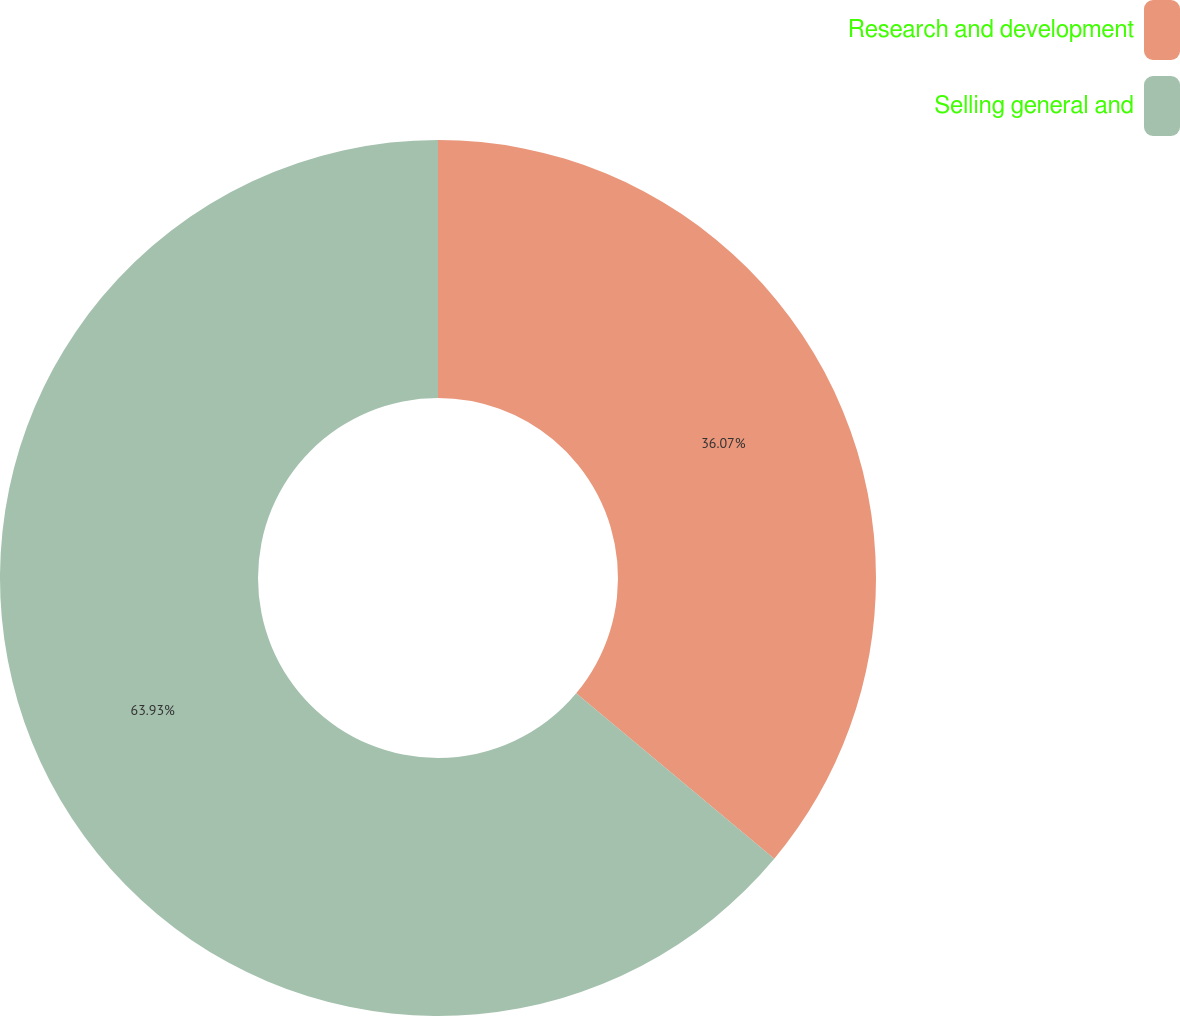Convert chart. <chart><loc_0><loc_0><loc_500><loc_500><pie_chart><fcel>Research and development<fcel>Selling general and<nl><fcel>36.07%<fcel>63.93%<nl></chart> 